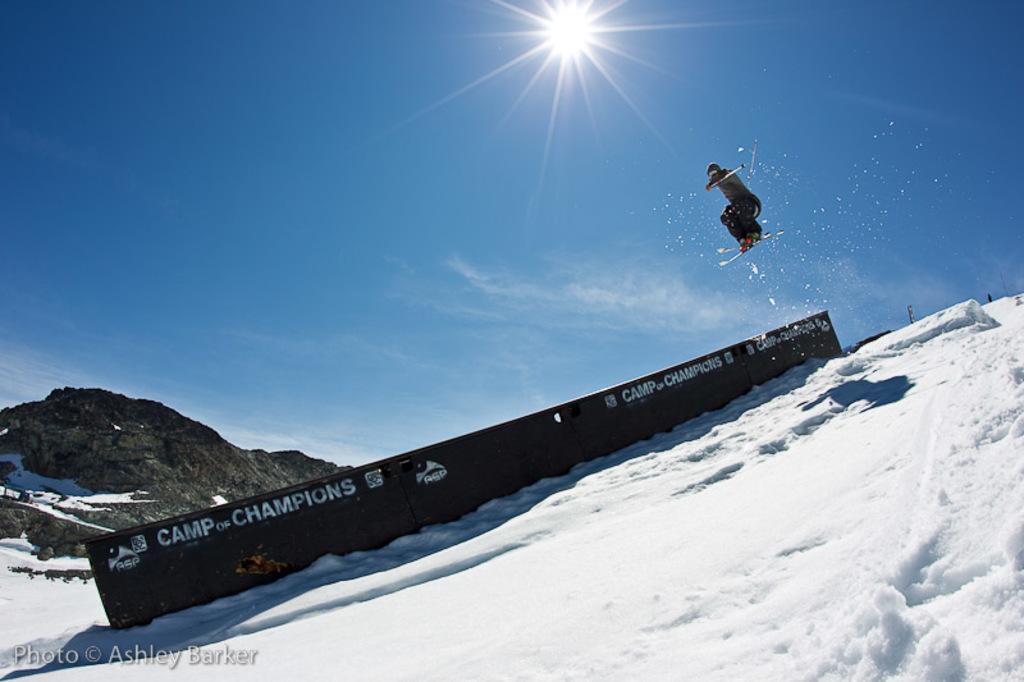Who is sponsoring this event?
Provide a succinct answer. Camp of champions. What is the guy doing?
Provide a succinct answer. Answering does not require reading text in the image. 